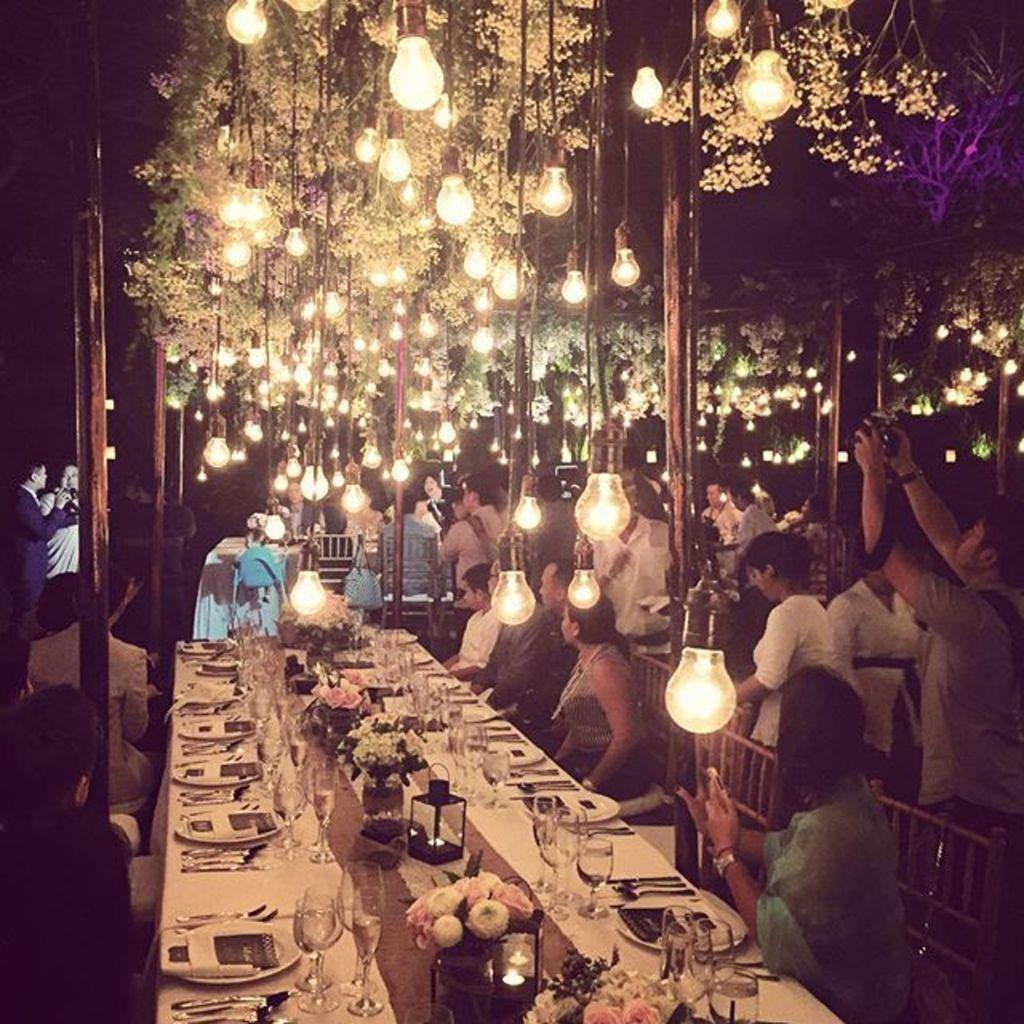Can you describe this image briefly? At the top of the image we can see poles, decors and electric lights hanging from the top. At the bottom of the image we can see some persons standing and some persons sitting on the chairs. There is a table in the middle of the image and cutlery, crockery, decors are placed on it. 